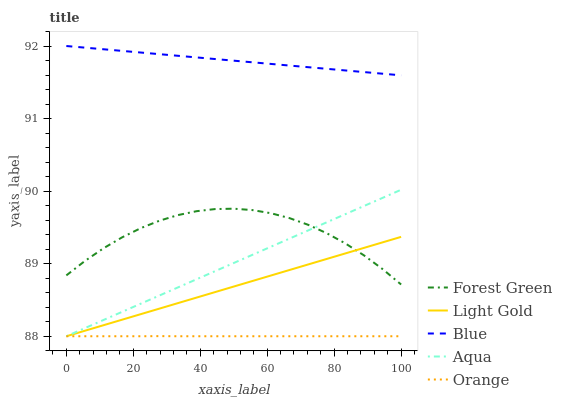Does Orange have the minimum area under the curve?
Answer yes or no. Yes. Does Blue have the maximum area under the curve?
Answer yes or no. Yes. Does Aqua have the minimum area under the curve?
Answer yes or no. No. Does Aqua have the maximum area under the curve?
Answer yes or no. No. Is Blue the smoothest?
Answer yes or no. Yes. Is Forest Green the roughest?
Answer yes or no. Yes. Is Aqua the smoothest?
Answer yes or no. No. Is Aqua the roughest?
Answer yes or no. No. Does Aqua have the lowest value?
Answer yes or no. Yes. Does Forest Green have the lowest value?
Answer yes or no. No. Does Blue have the highest value?
Answer yes or no. Yes. Does Aqua have the highest value?
Answer yes or no. No. Is Orange less than Forest Green?
Answer yes or no. Yes. Is Blue greater than Forest Green?
Answer yes or no. Yes. Does Light Gold intersect Aqua?
Answer yes or no. Yes. Is Light Gold less than Aqua?
Answer yes or no. No. Is Light Gold greater than Aqua?
Answer yes or no. No. Does Orange intersect Forest Green?
Answer yes or no. No. 